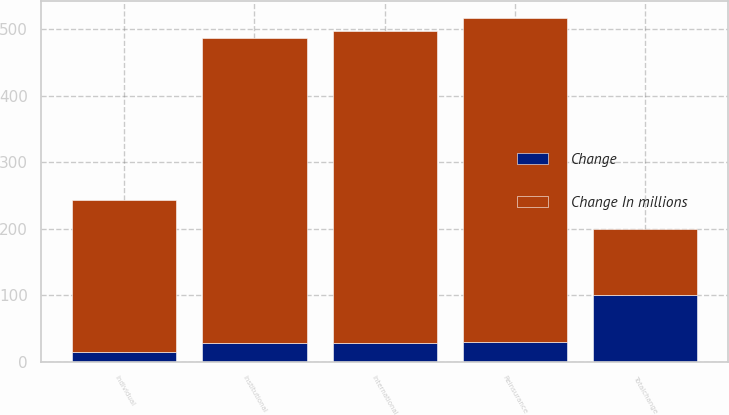Convert chart. <chart><loc_0><loc_0><loc_500><loc_500><stacked_bar_chart><ecel><fcel>Reinsurance<fcel>International<fcel>Institutional<fcel>Individual<fcel>Totalchange<nl><fcel>Change In millions<fcel>487<fcel>469<fcel>458<fcel>229<fcel>100<nl><fcel>Change<fcel>30<fcel>28<fcel>28<fcel>14<fcel>100<nl></chart> 